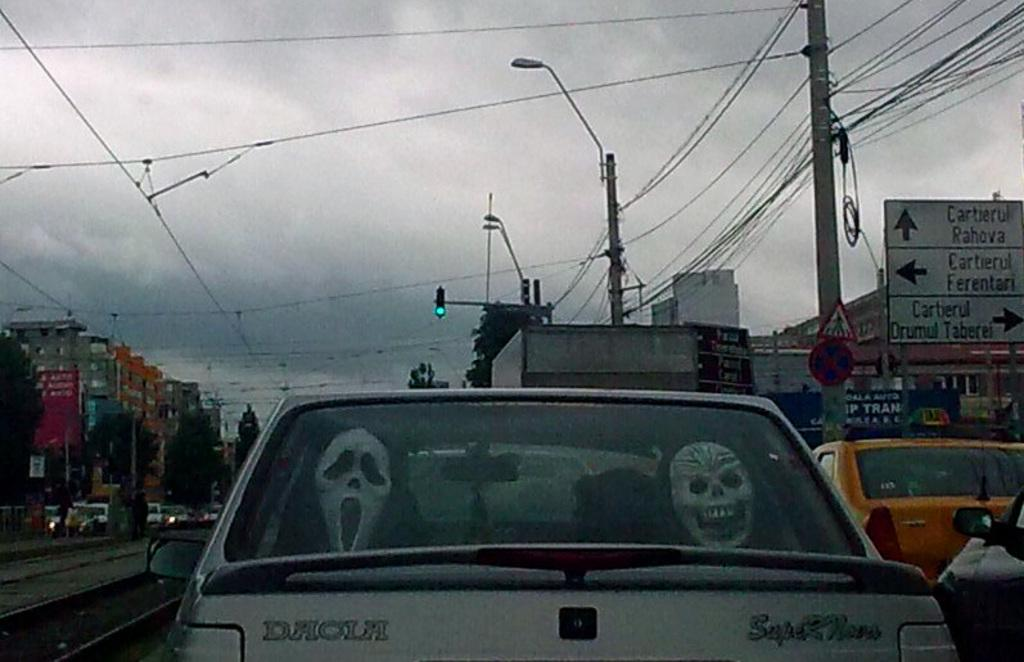Provide a one-sentence caption for the provided image. Two scary Halloween masks in the back window of a white Daola Car. 